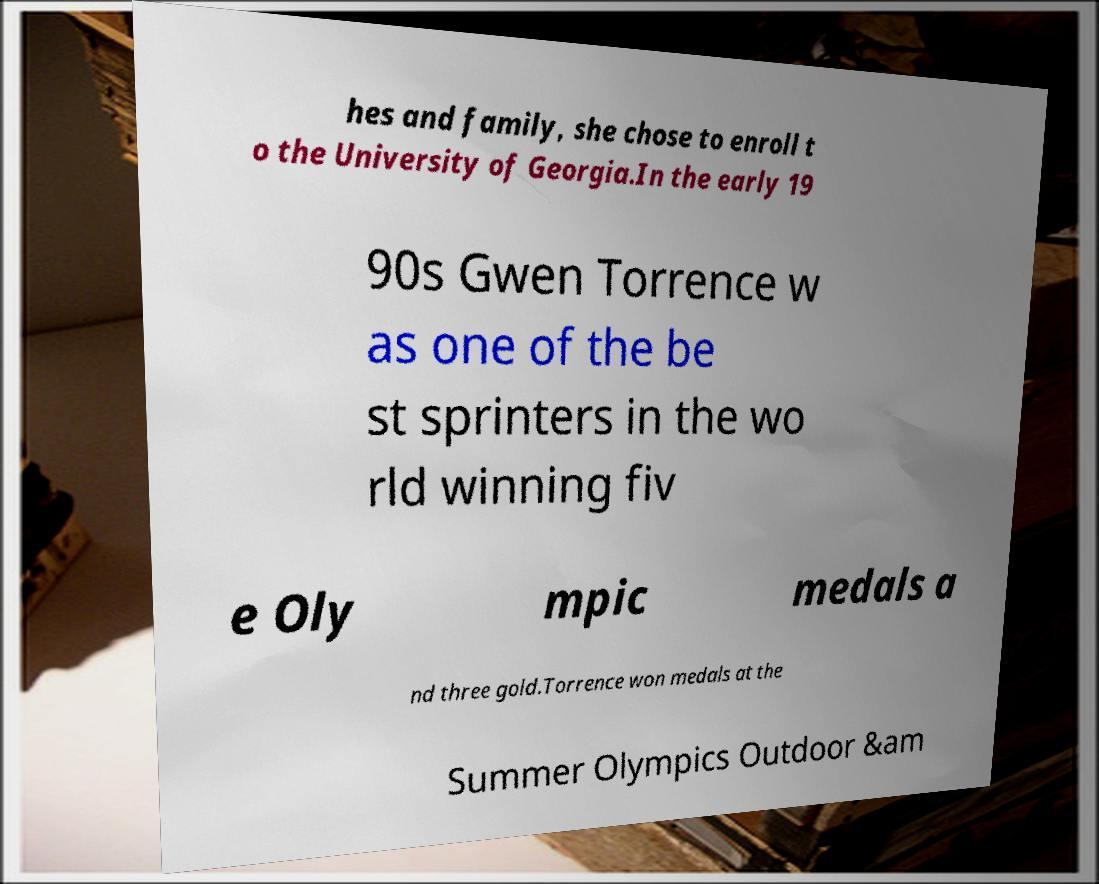Could you assist in decoding the text presented in this image and type it out clearly? hes and family, she chose to enroll t o the University of Georgia.In the early 19 90s Gwen Torrence w as one of the be st sprinters in the wo rld winning fiv e Oly mpic medals a nd three gold.Torrence won medals at the Summer Olympics Outdoor &am 